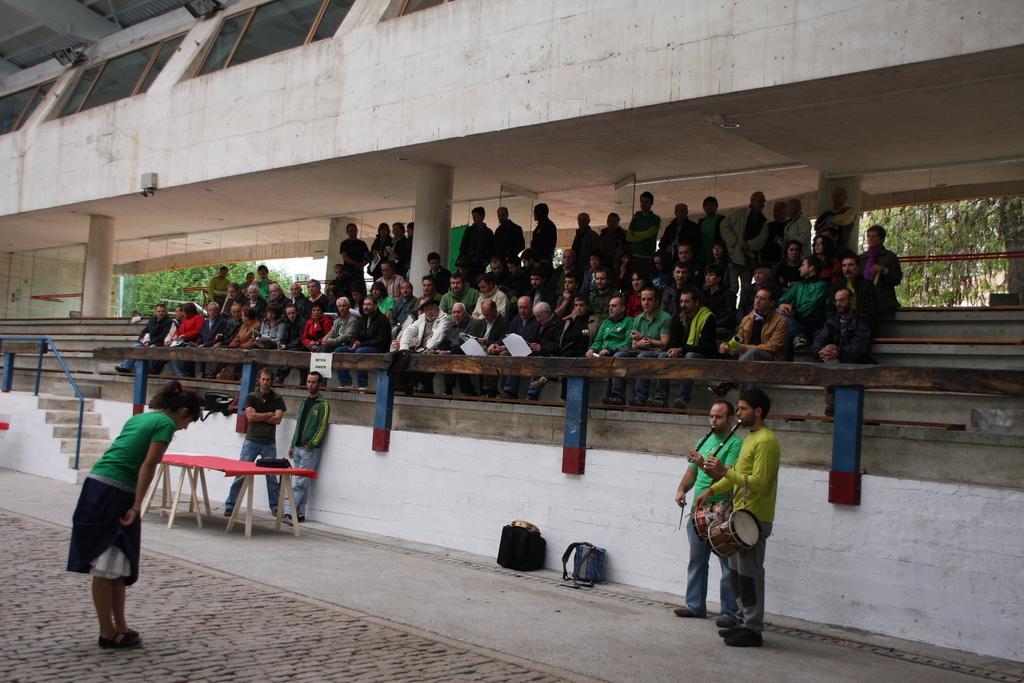Could you give a brief overview of what you see in this image? In this image, we can see so many peoples. Few are sat. At the back side, few are standing. We can see pillars here, windows, glass, lights. In the left side of the image, woman is standing. In the middle of the image, two are playing a musical instruments. Here we can see bags. There is a table. That is covered with red color cloth. Here we can see stairs and rod. At the background, we can see trees. 